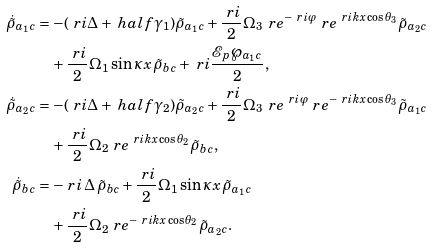Convert formula to latex. <formula><loc_0><loc_0><loc_500><loc_500>\dot { \tilde { \rho } } _ { a _ { 1 } c } & = - ( \ r i \Delta + \ h a l f \gamma _ { 1 } ) \tilde { \rho } _ { a _ { 1 } c } + \frac { \ r i } { 2 } \Omega _ { 3 } \, \ r e ^ { - \ r i \varphi } \ r e ^ { \ r i k x \cos \theta _ { 3 } } \tilde { \rho } _ { a _ { 2 } c } \\ & \quad + \frac { \ r i } { 2 } \Omega _ { 1 } \sin { \kappa x } \, \tilde { \rho } _ { b c } + \ r i \frac { \mathcal { E } _ { p } \wp _ { a _ { 1 } c } } { 2 } , \\ \dot { \tilde { \rho } } _ { a _ { 2 } c } & = - ( \ r i \Delta + \ h a l f \gamma _ { 2 } ) \tilde { \rho } _ { a _ { 2 } c } + \frac { \ r i } { 2 } \Omega _ { 3 } \, \ r e ^ { \ r i \varphi } \ r e ^ { - \ r i k x \cos \theta _ { 3 } } \tilde { \rho } _ { a _ { 1 } c } \\ & \quad + \frac { \ r i } { 2 } \Omega _ { 2 } \ r e ^ { \ r i k x \cos \theta _ { 2 } } \tilde { \rho } _ { b c } , \\ \dot { \tilde { \rho } } _ { b c } & = - \ r i \, \Delta \, \tilde { \rho } _ { b c } + \frac { \ r i } { 2 } \Omega _ { 1 } \sin { \kappa x } \, \tilde { \rho } _ { a _ { 1 } c } \\ & \quad + \frac { \ r i } { 2 } \Omega _ { 2 } \ r e ^ { - \ r i k x \cos \theta _ { 2 } } \tilde { \rho } _ { a _ { 2 } c } .</formula> 